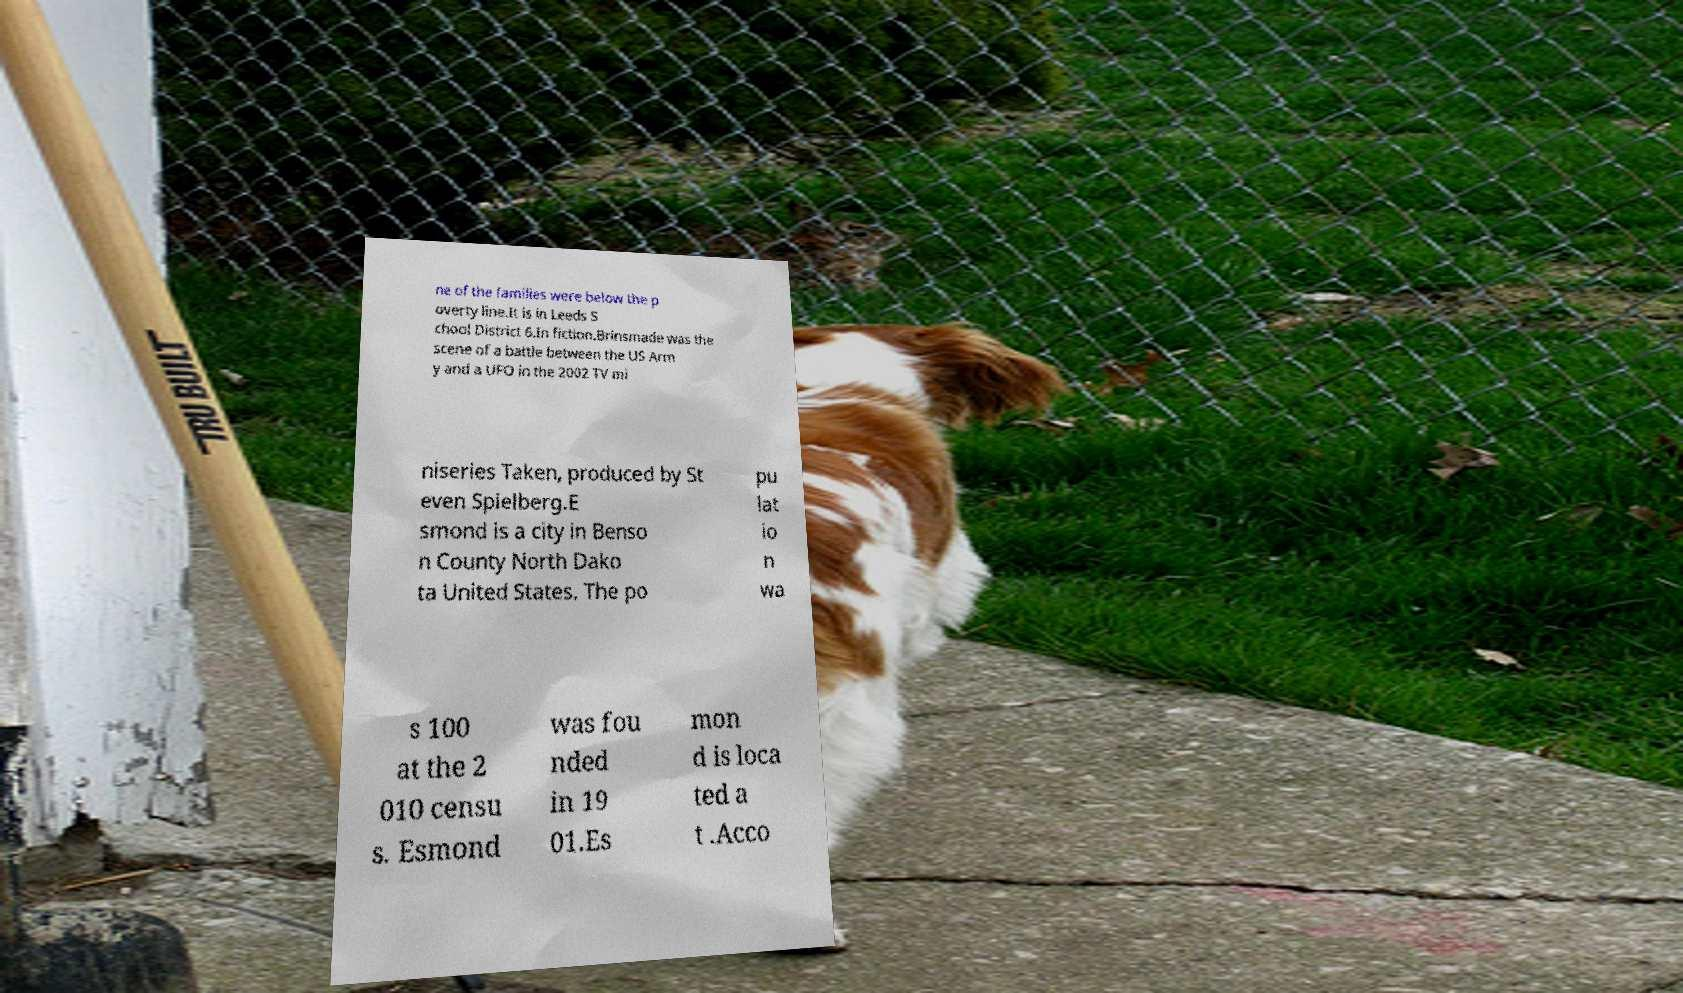What messages or text are displayed in this image? I need them in a readable, typed format. ne of the families were below the p overty line.It is in Leeds S chool District 6.In fiction.Brinsmade was the scene of a battle between the US Arm y and a UFO in the 2002 TV mi niseries Taken, produced by St even Spielberg.E smond is a city in Benso n County North Dako ta United States. The po pu lat io n wa s 100 at the 2 010 censu s. Esmond was fou nded in 19 01.Es mon d is loca ted a t .Acco 